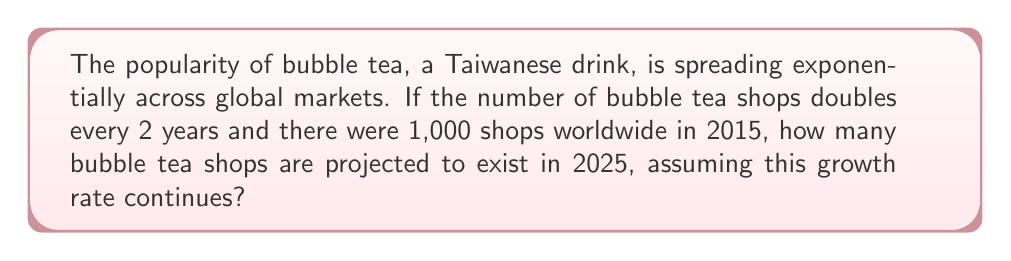Can you answer this question? Let's approach this step-by-step:

1) First, we need to determine how many 2-year periods have passed from 2015 to 2025:
   2025 - 2015 = 10 years
   10 years ÷ 2 years per period = 5 periods

2) We can express this as an exponential function:
   $$ N = 1000 \cdot 2^x $$
   Where N is the number of shops and x is the number of 2-year periods.

3) We know x = 5, so let's substitute this:
   $$ N = 1000 \cdot 2^5 $$

4) Now, let's calculate $2^5$:
   $$ 2^5 = 2 \cdot 2 \cdot 2 \cdot 2 \cdot 2 = 32 $$

5) Therefore:
   $$ N = 1000 \cdot 32 = 32,000 $$

Thus, if the exponential growth continues at this rate, there will be 32,000 bubble tea shops worldwide by 2025.
Answer: 32,000 shops 